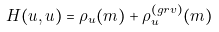Convert formula to latex. <formula><loc_0><loc_0><loc_500><loc_500>H ( u , u ) = \rho _ { u } ( m ) + \rho _ { u } ^ { ( g r v ) } ( m )</formula> 